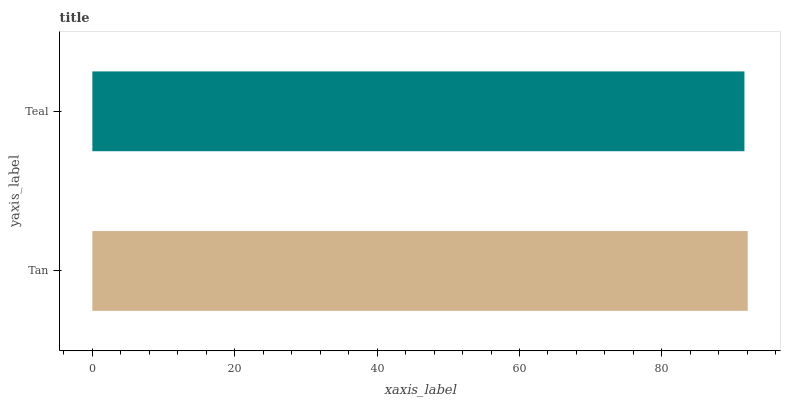Is Teal the minimum?
Answer yes or no. Yes. Is Tan the maximum?
Answer yes or no. Yes. Is Teal the maximum?
Answer yes or no. No. Is Tan greater than Teal?
Answer yes or no. Yes. Is Teal less than Tan?
Answer yes or no. Yes. Is Teal greater than Tan?
Answer yes or no. No. Is Tan less than Teal?
Answer yes or no. No. Is Tan the high median?
Answer yes or no. Yes. Is Teal the low median?
Answer yes or no. Yes. Is Teal the high median?
Answer yes or no. No. Is Tan the low median?
Answer yes or no. No. 